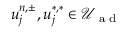Convert formula to latex. <formula><loc_0><loc_0><loc_500><loc_500>u _ { j } ^ { n , \pm } , u _ { j } ^ { \ast , \ast } \in \mathcal { U } _ { a d }</formula> 